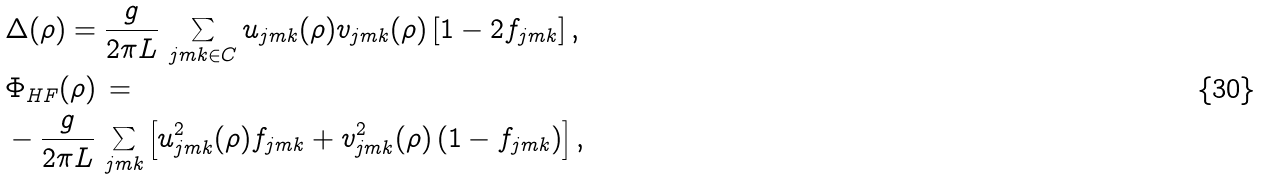<formula> <loc_0><loc_0><loc_500><loc_500>& \Delta ( \rho ) = \frac { g } { 2 \pi L } \, \sum _ { j m k \in C } u _ { j m k } ( \rho ) v _ { j m k } ( \rho ) \left [ 1 - 2 f _ { j m k } \right ] , \\ & \Phi _ { H F } ( \rho ) \, = \\ & - \frac { g } { 2 \pi L } \, \sum _ { j m k } \left [ u ^ { 2 } _ { j m k } ( \rho ) f _ { j m k } + v ^ { 2 } _ { j m k } ( \rho ) \left ( 1 - f _ { j m k } \right ) \right ] ,</formula> 